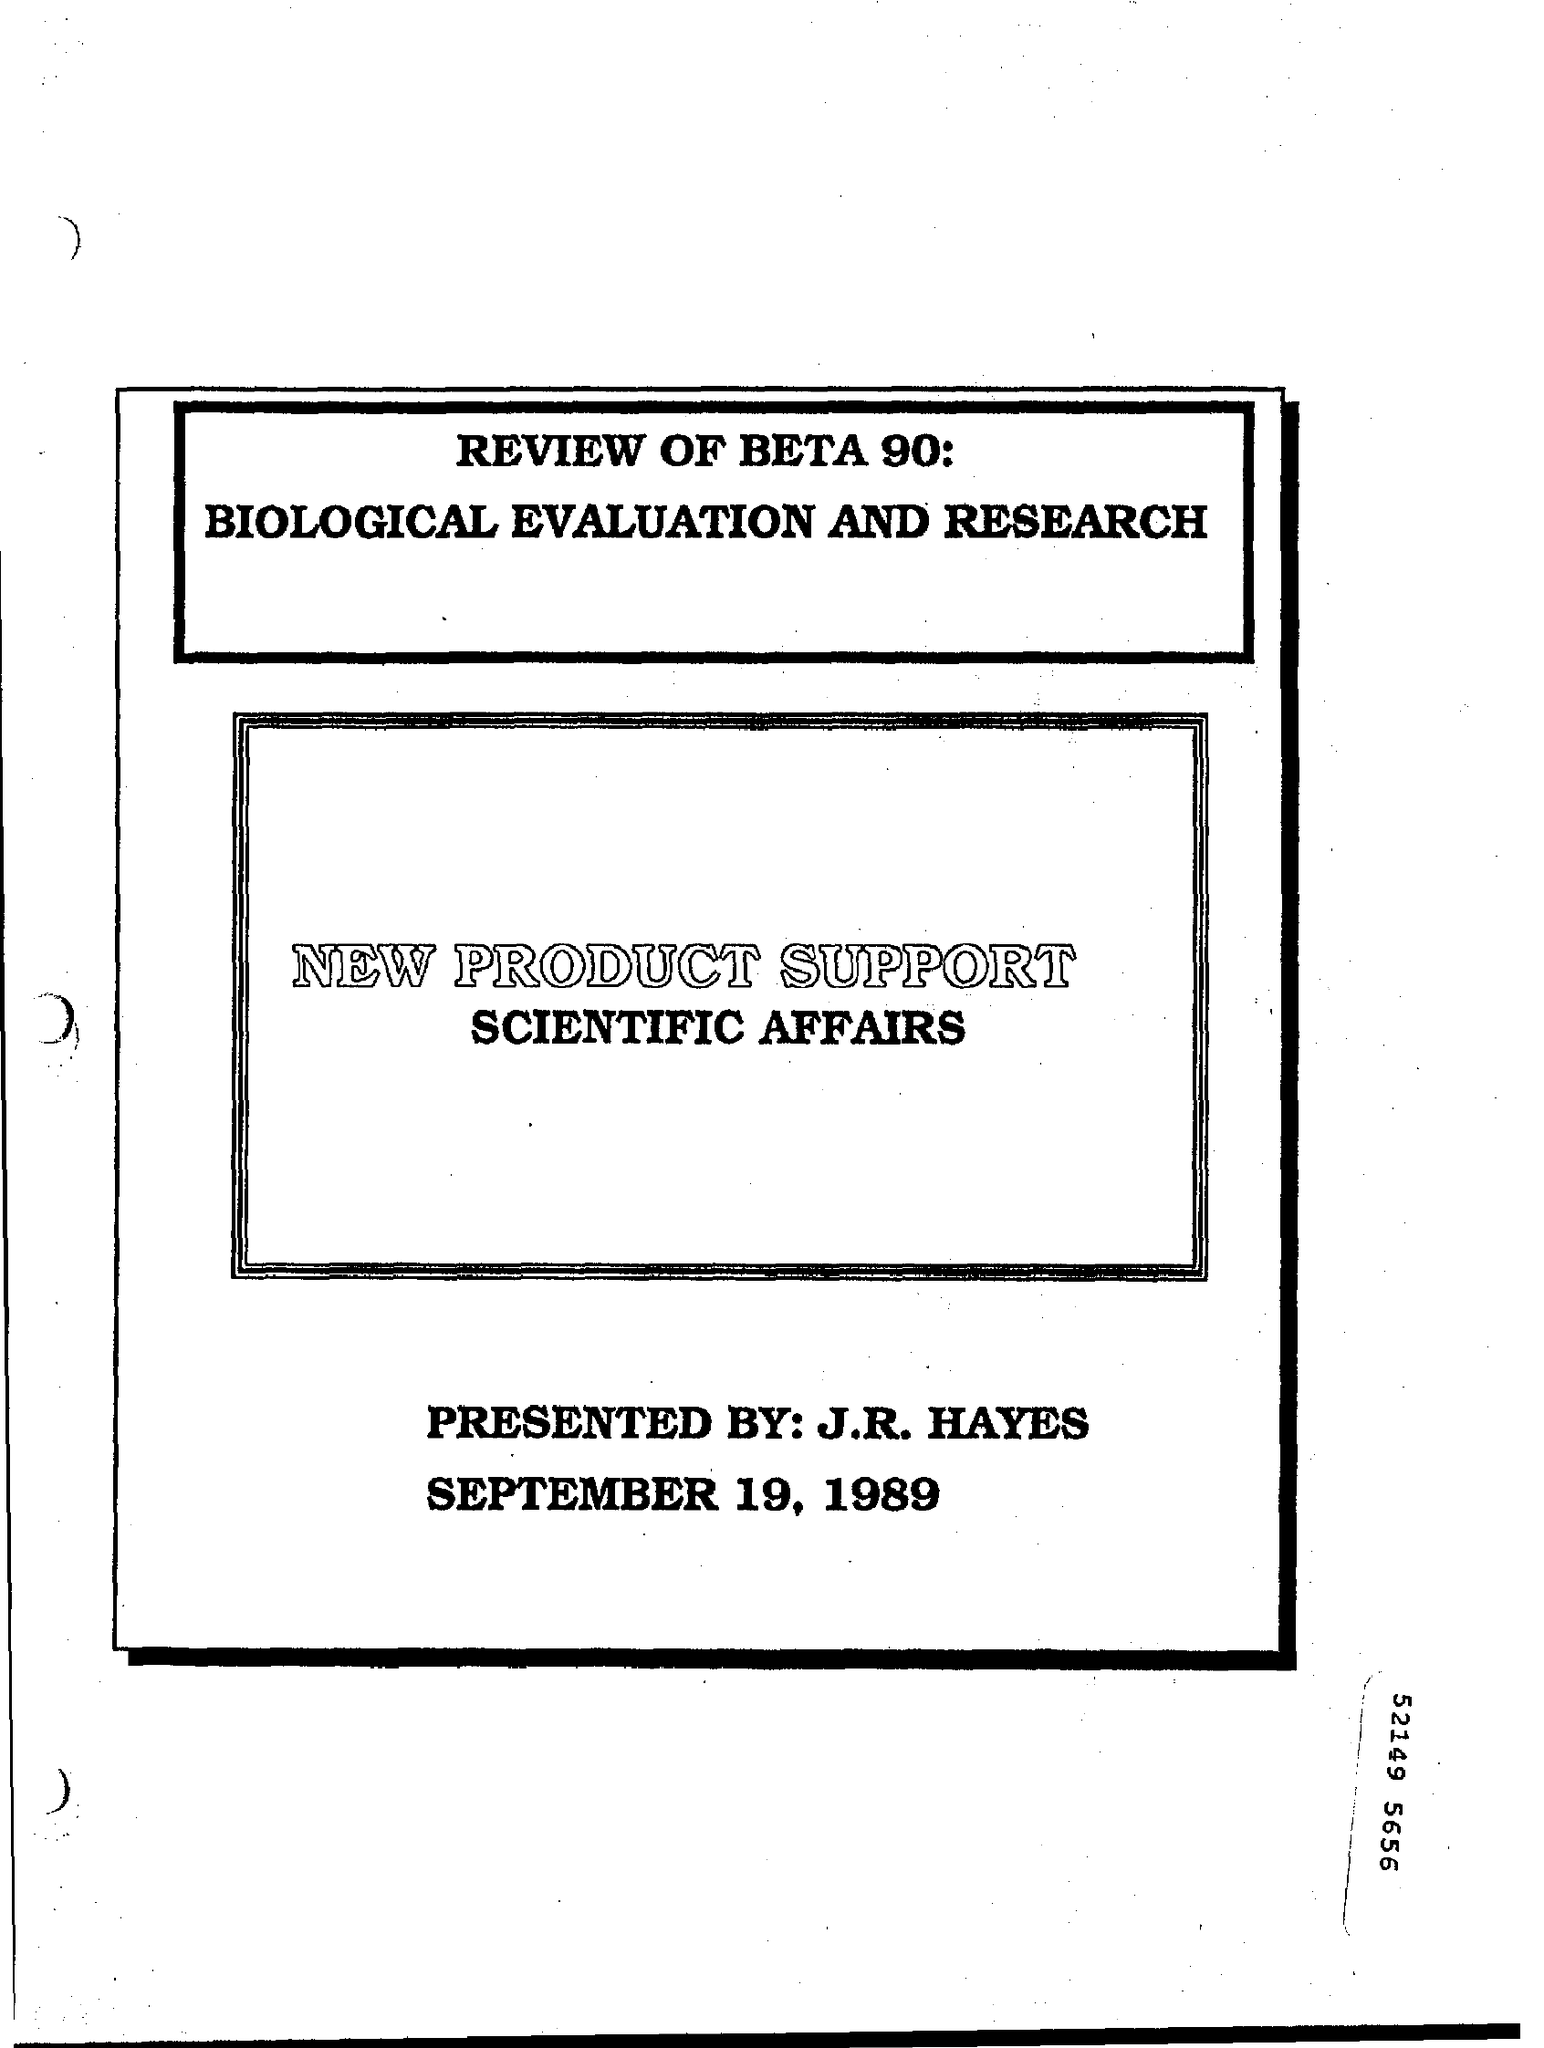What is written in first rectangle at the top of the page?
Your answer should be compact. REVIEW OF BETA 90: BIOLOGICAL EVALUATION AND RESEARCH. What is written inside second rectangle of the page as main heading?
Provide a short and direct response. NEW PRODUCT SUPPORT. What is written inside second rectangle of the page below "NEW PRODUCT SUPPORT"?
Ensure brevity in your answer.  SCIENTIFIC AFFAIRS. Who has PRESENTED this?
Provide a succinct answer. J.R. HAYES. 